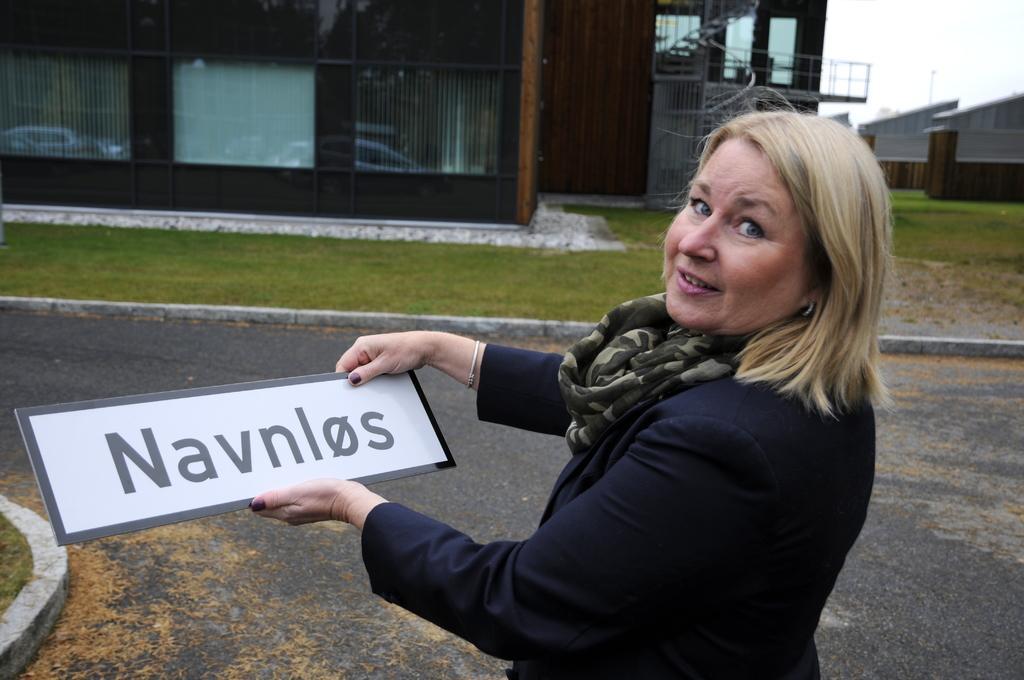In one or two sentences, can you explain what this image depicts? In the image there is a blond haired woman in black suit holding a name board, in the back there is a home in front of garden and above its sky. 